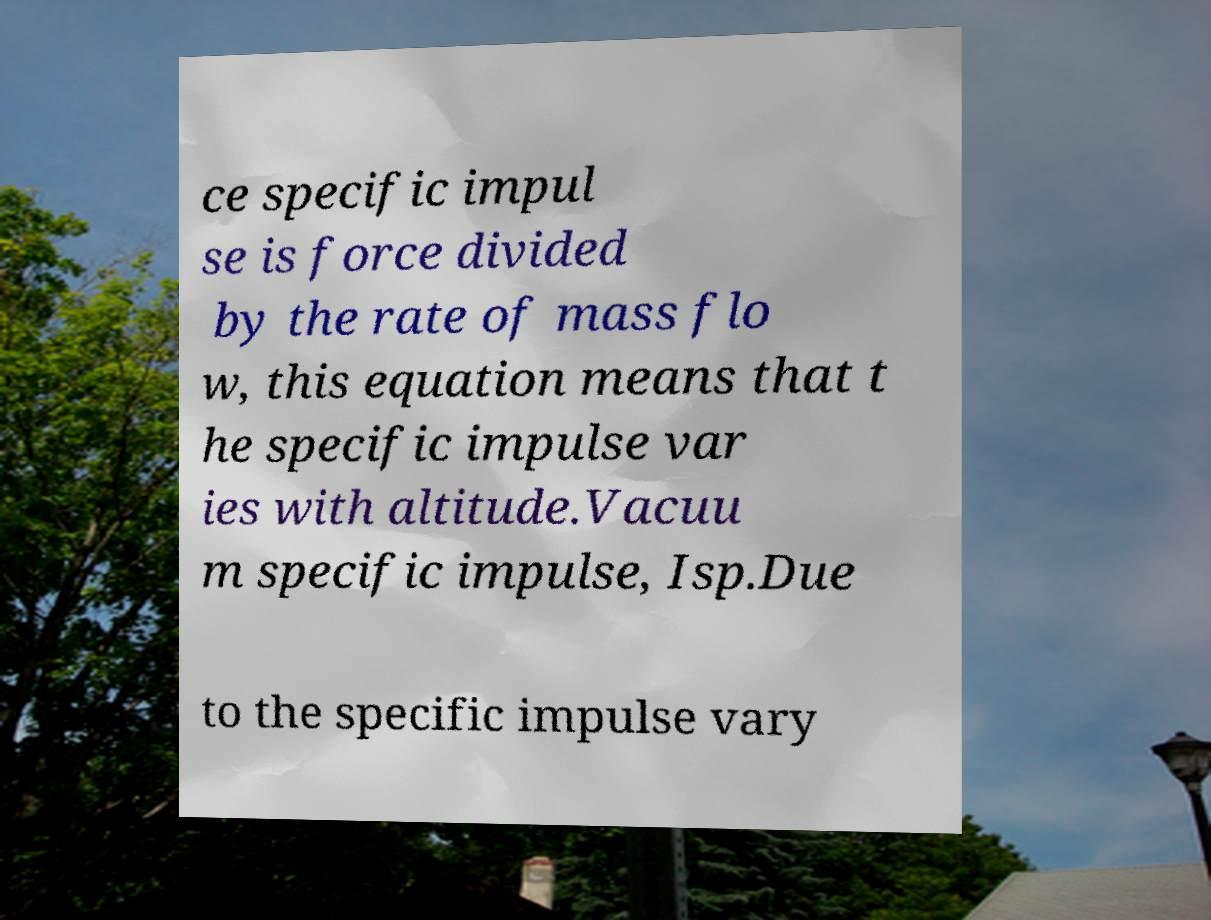Could you assist in decoding the text presented in this image and type it out clearly? ce specific impul se is force divided by the rate of mass flo w, this equation means that t he specific impulse var ies with altitude.Vacuu m specific impulse, Isp.Due to the specific impulse vary 